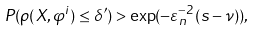Convert formula to latex. <formula><loc_0><loc_0><loc_500><loc_500>P ( \rho ( X , \varphi ^ { i } ) \leq \delta ^ { \prime } ) > \exp ( - \varepsilon _ { n } ^ { - 2 } ( s - \nu ) ) ,</formula> 